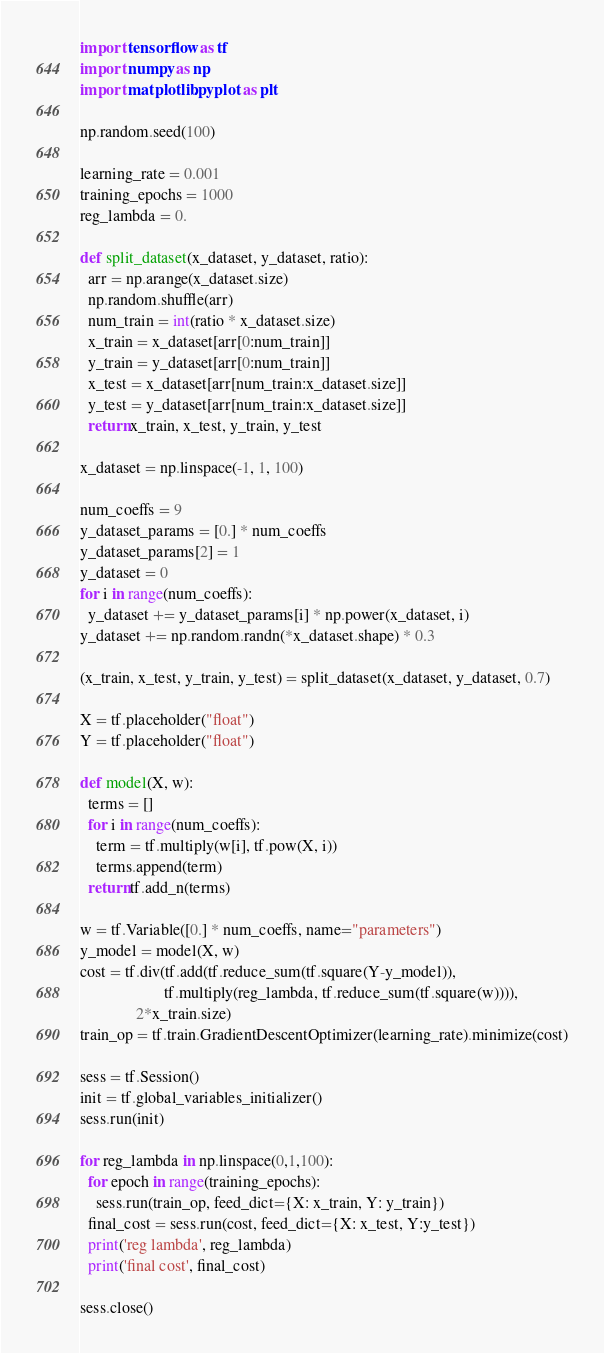Convert code to text. <code><loc_0><loc_0><loc_500><loc_500><_Python_>import tensorflow as tf
import numpy as np
import matplotlib.pyplot as plt

np.random.seed(100)

learning_rate = 0.001
training_epochs = 1000
reg_lambda = 0.

def split_dataset(x_dataset, y_dataset, ratio):
  arr = np.arange(x_dataset.size)
  np.random.shuffle(arr)
  num_train = int(ratio * x_dataset.size)
  x_train = x_dataset[arr[0:num_train]]
  y_train = y_dataset[arr[0:num_train]]
  x_test = x_dataset[arr[num_train:x_dataset.size]]
  y_test = y_dataset[arr[num_train:x_dataset.size]]
  return x_train, x_test, y_train, y_test
	
x_dataset = np.linspace(-1, 1, 100)

num_coeffs = 9
y_dataset_params = [0.] * num_coeffs
y_dataset_params[2] = 1
y_dataset = 0
for i in range(num_coeffs):
  y_dataset += y_dataset_params[i] * np.power(x_dataset, i)
y_dataset += np.random.randn(*x_dataset.shape) * 0.3

(x_train, x_test, y_train, y_test) = split_dataset(x_dataset, y_dataset, 0.7)

X = tf.placeholder("float")
Y = tf.placeholder("float")

def model(X, w):
  terms = []
  for i in range(num_coeffs):
    term = tf.multiply(w[i], tf.pow(X, i))
    terms.append(term)
  return tf.add_n(terms)
  
w = tf.Variable([0.] * num_coeffs, name="parameters")
y_model = model(X, w)
cost = tf.div(tf.add(tf.reduce_sum(tf.square(Y-y_model)),
                     tf.multiply(reg_lambda, tf.reduce_sum(tf.square(w)))),
              2*x_train.size)
train_op = tf.train.GradientDescentOptimizer(learning_rate).minimize(cost)

sess = tf.Session()
init = tf.global_variables_initializer()
sess.run(init)

for reg_lambda in np.linspace(0,1,100):
  for epoch in range(training_epochs):
    sess.run(train_op, feed_dict={X: x_train, Y: y_train})
  final_cost = sess.run(cost, feed_dict={X: x_test, Y:y_test})
  print('reg lambda', reg_lambda)
  print('final cost', final_cost)
  
sess.close()</code> 